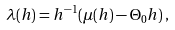<formula> <loc_0><loc_0><loc_500><loc_500>\lambda ( h ) = h ^ { - 1 } ( \mu ( h ) - \Theta _ { 0 } h ) \, ,</formula> 